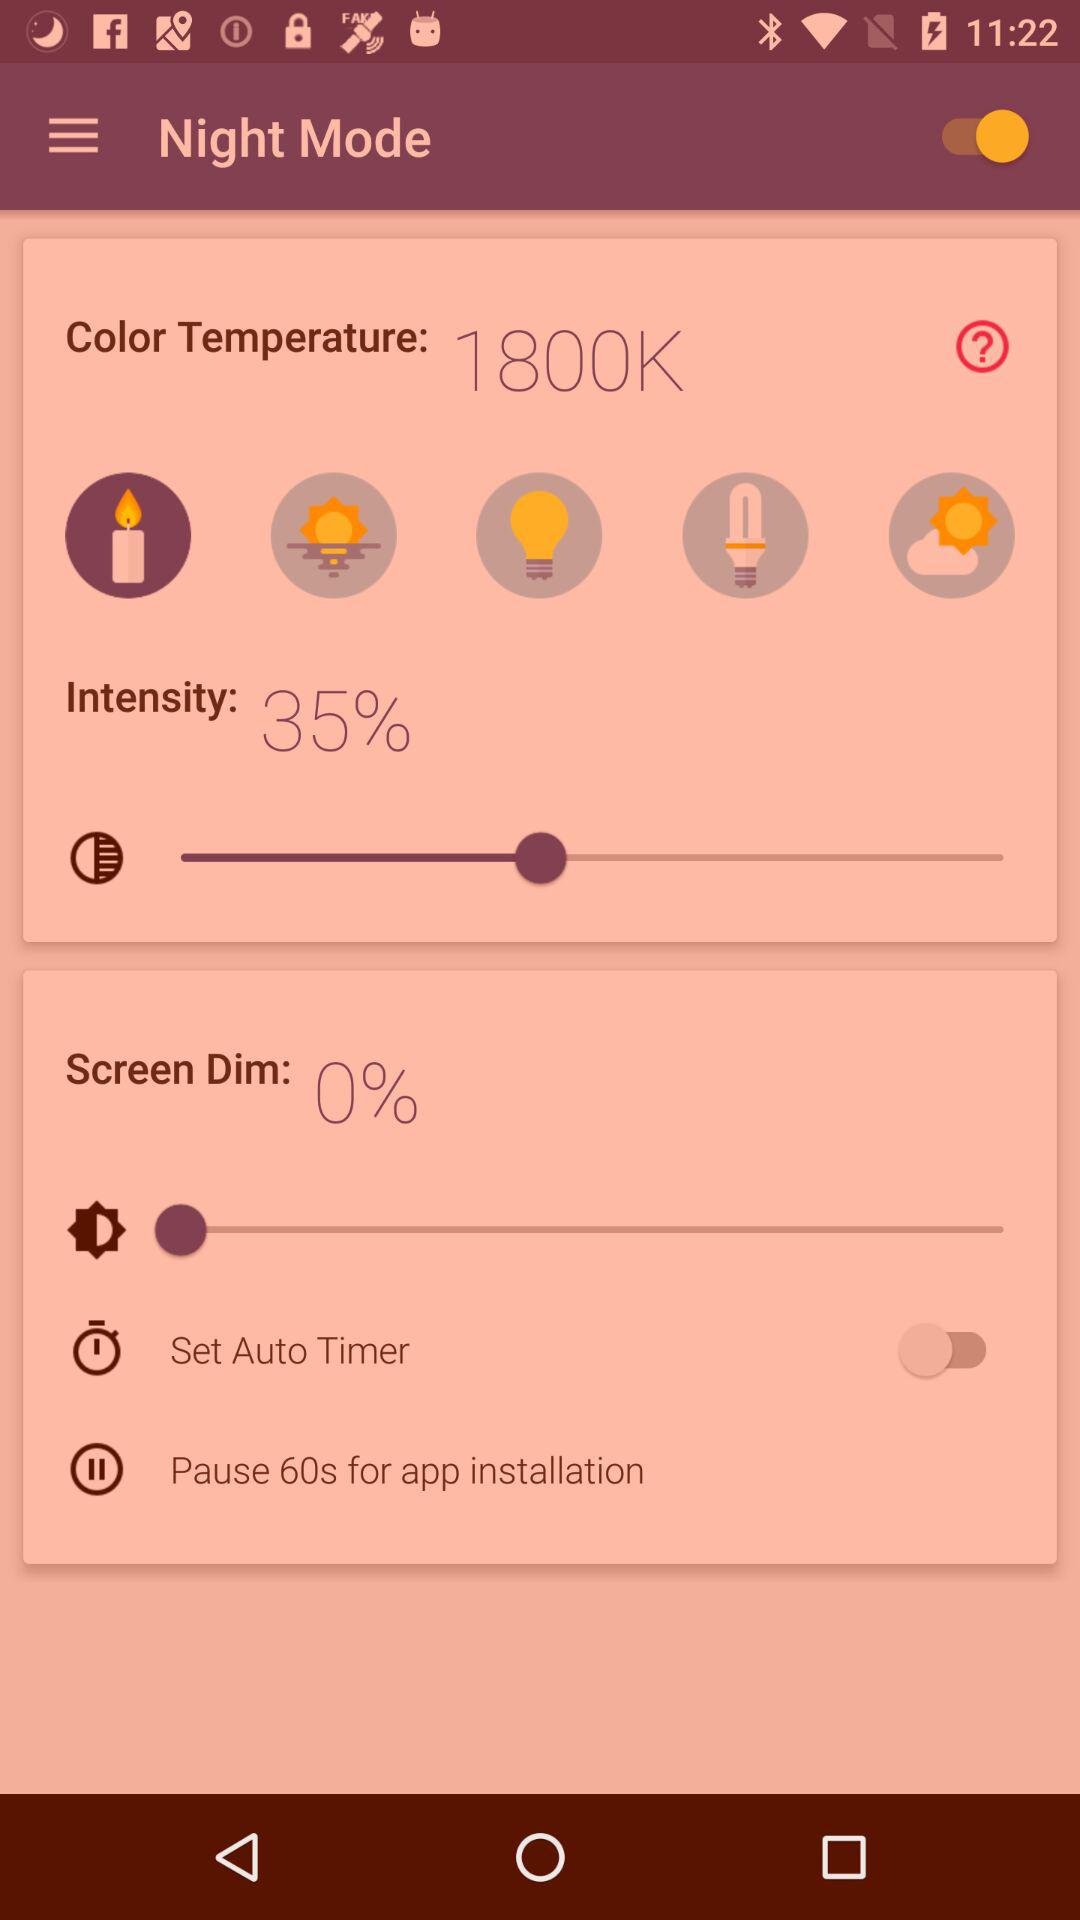How much is the maximum screen brightness?
When the provided information is insufficient, respond with <no answer>. <no answer> 